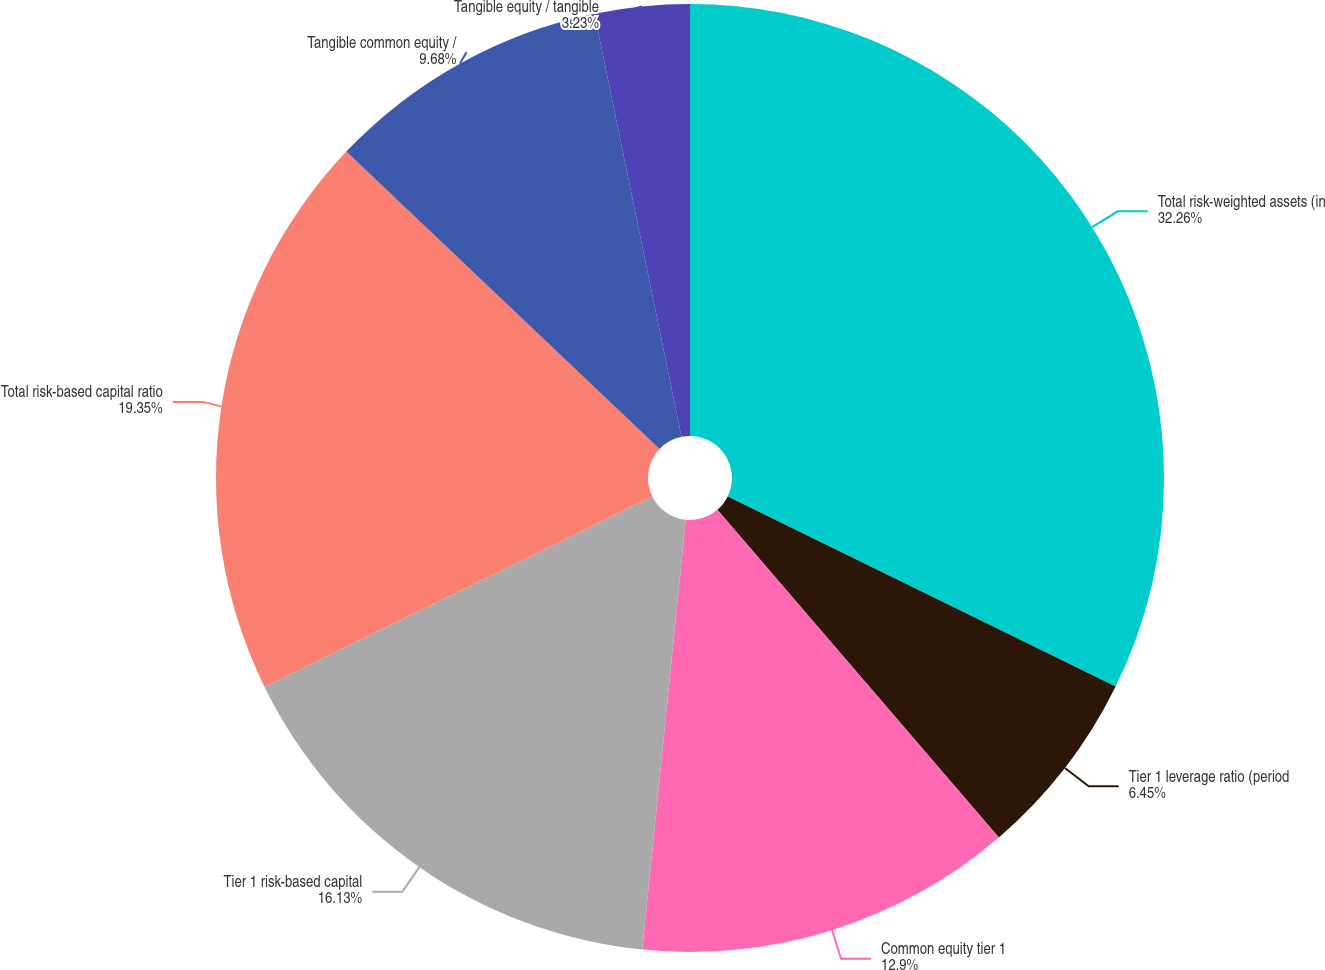<chart> <loc_0><loc_0><loc_500><loc_500><pie_chart><fcel>Total risk-weighted assets (in<fcel>Tier 1 leverage ratio (period<fcel>Common equity tier 1<fcel>Tier 1 risk-based capital<fcel>Total risk-based capital ratio<fcel>Tangible common equity /<fcel>Tangible equity / tangible<nl><fcel>32.25%<fcel>6.45%<fcel>12.9%<fcel>16.13%<fcel>19.35%<fcel>9.68%<fcel>3.23%<nl></chart> 